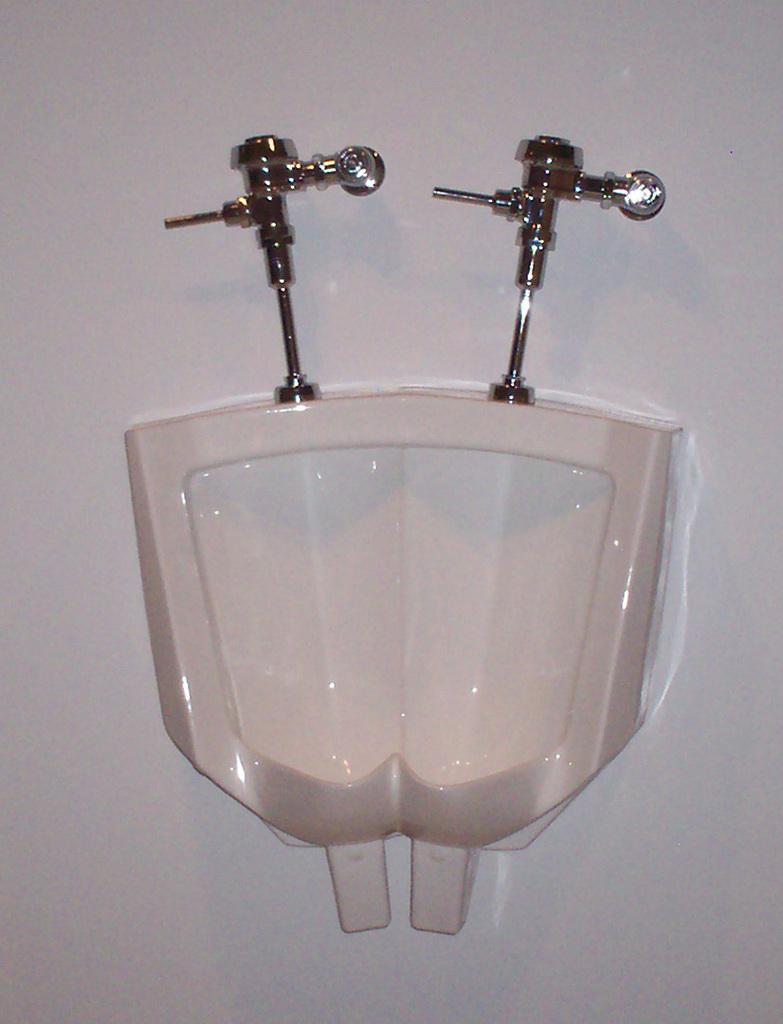Could you give a brief overview of what you see in this image? In this image we can see urinals, taps and the wall. 